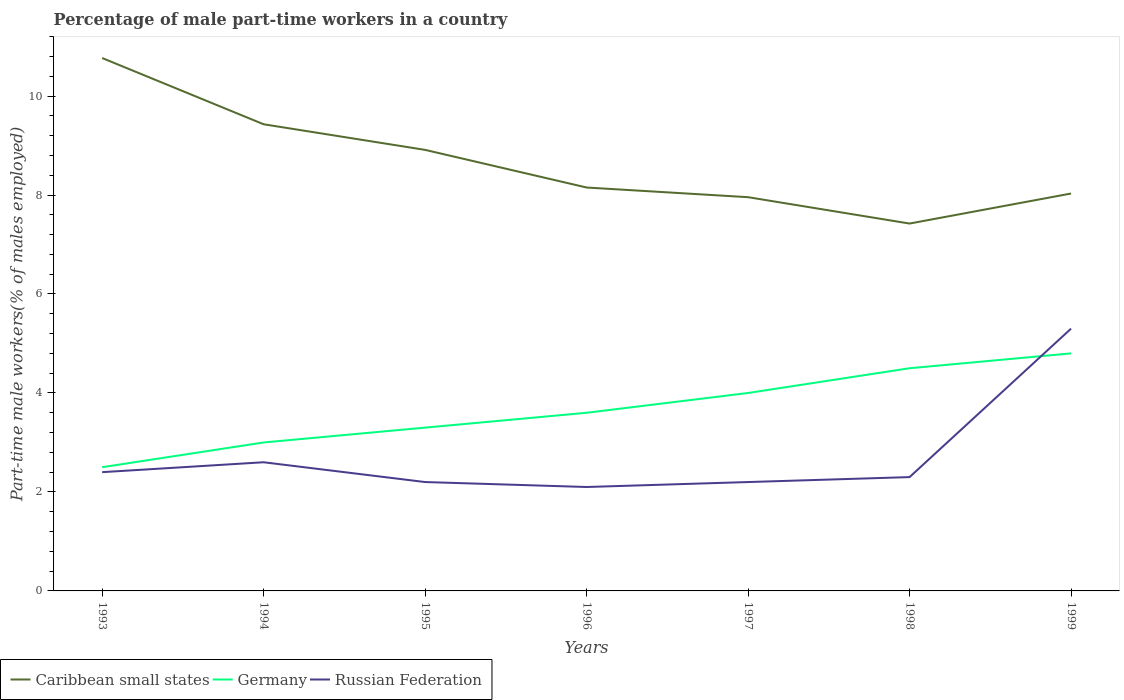Does the line corresponding to Germany intersect with the line corresponding to Russian Federation?
Ensure brevity in your answer.  Yes. Across all years, what is the maximum percentage of male part-time workers in Caribbean small states?
Keep it short and to the point. 7.42. In which year was the percentage of male part-time workers in Caribbean small states maximum?
Offer a very short reply. 1998. What is the total percentage of male part-time workers in Russian Federation in the graph?
Your answer should be compact. 0.1. What is the difference between the highest and the second highest percentage of male part-time workers in Russian Federation?
Keep it short and to the point. 3.2. What is the difference between the highest and the lowest percentage of male part-time workers in Caribbean small states?
Give a very brief answer. 3. How many years are there in the graph?
Your answer should be compact. 7. How many legend labels are there?
Your answer should be very brief. 3. How are the legend labels stacked?
Ensure brevity in your answer.  Horizontal. What is the title of the graph?
Your answer should be compact. Percentage of male part-time workers in a country. What is the label or title of the Y-axis?
Ensure brevity in your answer.  Part-time male workers(% of males employed). What is the Part-time male workers(% of males employed) in Caribbean small states in 1993?
Keep it short and to the point. 10.77. What is the Part-time male workers(% of males employed) in Germany in 1993?
Your answer should be compact. 2.5. What is the Part-time male workers(% of males employed) of Russian Federation in 1993?
Make the answer very short. 2.4. What is the Part-time male workers(% of males employed) of Caribbean small states in 1994?
Provide a short and direct response. 9.43. What is the Part-time male workers(% of males employed) in Russian Federation in 1994?
Your answer should be compact. 2.6. What is the Part-time male workers(% of males employed) of Caribbean small states in 1995?
Your response must be concise. 8.91. What is the Part-time male workers(% of males employed) in Germany in 1995?
Make the answer very short. 3.3. What is the Part-time male workers(% of males employed) of Russian Federation in 1995?
Offer a very short reply. 2.2. What is the Part-time male workers(% of males employed) in Caribbean small states in 1996?
Your response must be concise. 8.15. What is the Part-time male workers(% of males employed) of Germany in 1996?
Your answer should be very brief. 3.6. What is the Part-time male workers(% of males employed) of Russian Federation in 1996?
Keep it short and to the point. 2.1. What is the Part-time male workers(% of males employed) of Caribbean small states in 1997?
Your response must be concise. 7.96. What is the Part-time male workers(% of males employed) in Russian Federation in 1997?
Your answer should be compact. 2.2. What is the Part-time male workers(% of males employed) in Caribbean small states in 1998?
Keep it short and to the point. 7.42. What is the Part-time male workers(% of males employed) in Germany in 1998?
Provide a succinct answer. 4.5. What is the Part-time male workers(% of males employed) of Russian Federation in 1998?
Offer a terse response. 2.3. What is the Part-time male workers(% of males employed) of Caribbean small states in 1999?
Offer a very short reply. 8.03. What is the Part-time male workers(% of males employed) in Germany in 1999?
Provide a short and direct response. 4.8. What is the Part-time male workers(% of males employed) in Russian Federation in 1999?
Give a very brief answer. 5.3. Across all years, what is the maximum Part-time male workers(% of males employed) of Caribbean small states?
Offer a very short reply. 10.77. Across all years, what is the maximum Part-time male workers(% of males employed) of Germany?
Your answer should be compact. 4.8. Across all years, what is the maximum Part-time male workers(% of males employed) of Russian Federation?
Your response must be concise. 5.3. Across all years, what is the minimum Part-time male workers(% of males employed) in Caribbean small states?
Provide a short and direct response. 7.42. Across all years, what is the minimum Part-time male workers(% of males employed) in Russian Federation?
Provide a succinct answer. 2.1. What is the total Part-time male workers(% of males employed) in Caribbean small states in the graph?
Offer a terse response. 60.67. What is the total Part-time male workers(% of males employed) of Germany in the graph?
Provide a short and direct response. 25.7. What is the total Part-time male workers(% of males employed) in Russian Federation in the graph?
Your answer should be very brief. 19.1. What is the difference between the Part-time male workers(% of males employed) of Caribbean small states in 1993 and that in 1994?
Keep it short and to the point. 1.34. What is the difference between the Part-time male workers(% of males employed) in Caribbean small states in 1993 and that in 1995?
Offer a terse response. 1.86. What is the difference between the Part-time male workers(% of males employed) of Caribbean small states in 1993 and that in 1996?
Provide a succinct answer. 2.62. What is the difference between the Part-time male workers(% of males employed) of Germany in 1993 and that in 1996?
Provide a short and direct response. -1.1. What is the difference between the Part-time male workers(% of males employed) in Russian Federation in 1993 and that in 1996?
Your response must be concise. 0.3. What is the difference between the Part-time male workers(% of males employed) of Caribbean small states in 1993 and that in 1997?
Make the answer very short. 2.81. What is the difference between the Part-time male workers(% of males employed) of Caribbean small states in 1993 and that in 1998?
Your answer should be compact. 3.34. What is the difference between the Part-time male workers(% of males employed) of Germany in 1993 and that in 1998?
Provide a short and direct response. -2. What is the difference between the Part-time male workers(% of males employed) of Caribbean small states in 1993 and that in 1999?
Give a very brief answer. 2.74. What is the difference between the Part-time male workers(% of males employed) of Germany in 1993 and that in 1999?
Your answer should be compact. -2.3. What is the difference between the Part-time male workers(% of males employed) in Russian Federation in 1993 and that in 1999?
Your response must be concise. -2.9. What is the difference between the Part-time male workers(% of males employed) in Caribbean small states in 1994 and that in 1995?
Your response must be concise. 0.52. What is the difference between the Part-time male workers(% of males employed) of Germany in 1994 and that in 1995?
Offer a terse response. -0.3. What is the difference between the Part-time male workers(% of males employed) in Russian Federation in 1994 and that in 1995?
Your response must be concise. 0.4. What is the difference between the Part-time male workers(% of males employed) of Caribbean small states in 1994 and that in 1996?
Your answer should be very brief. 1.28. What is the difference between the Part-time male workers(% of males employed) of Germany in 1994 and that in 1996?
Make the answer very short. -0.6. What is the difference between the Part-time male workers(% of males employed) of Caribbean small states in 1994 and that in 1997?
Your answer should be very brief. 1.47. What is the difference between the Part-time male workers(% of males employed) of Russian Federation in 1994 and that in 1997?
Your answer should be very brief. 0.4. What is the difference between the Part-time male workers(% of males employed) in Caribbean small states in 1994 and that in 1998?
Your answer should be compact. 2.01. What is the difference between the Part-time male workers(% of males employed) of Germany in 1994 and that in 1998?
Keep it short and to the point. -1.5. What is the difference between the Part-time male workers(% of males employed) of Caribbean small states in 1994 and that in 1999?
Your answer should be compact. 1.4. What is the difference between the Part-time male workers(% of males employed) of Caribbean small states in 1995 and that in 1996?
Your answer should be very brief. 0.76. What is the difference between the Part-time male workers(% of males employed) in Germany in 1995 and that in 1996?
Your answer should be compact. -0.3. What is the difference between the Part-time male workers(% of males employed) of Russian Federation in 1995 and that in 1996?
Give a very brief answer. 0.1. What is the difference between the Part-time male workers(% of males employed) in Caribbean small states in 1995 and that in 1997?
Offer a terse response. 0.96. What is the difference between the Part-time male workers(% of males employed) of Caribbean small states in 1995 and that in 1998?
Your response must be concise. 1.49. What is the difference between the Part-time male workers(% of males employed) in Russian Federation in 1995 and that in 1998?
Ensure brevity in your answer.  -0.1. What is the difference between the Part-time male workers(% of males employed) in Caribbean small states in 1995 and that in 1999?
Offer a very short reply. 0.88. What is the difference between the Part-time male workers(% of males employed) of Caribbean small states in 1996 and that in 1997?
Offer a terse response. 0.2. What is the difference between the Part-time male workers(% of males employed) in Germany in 1996 and that in 1997?
Your response must be concise. -0.4. What is the difference between the Part-time male workers(% of males employed) in Russian Federation in 1996 and that in 1997?
Your response must be concise. -0.1. What is the difference between the Part-time male workers(% of males employed) of Caribbean small states in 1996 and that in 1998?
Provide a succinct answer. 0.73. What is the difference between the Part-time male workers(% of males employed) of Germany in 1996 and that in 1998?
Your answer should be very brief. -0.9. What is the difference between the Part-time male workers(% of males employed) in Russian Federation in 1996 and that in 1998?
Provide a short and direct response. -0.2. What is the difference between the Part-time male workers(% of males employed) of Caribbean small states in 1996 and that in 1999?
Keep it short and to the point. 0.12. What is the difference between the Part-time male workers(% of males employed) in Germany in 1996 and that in 1999?
Ensure brevity in your answer.  -1.2. What is the difference between the Part-time male workers(% of males employed) of Russian Federation in 1996 and that in 1999?
Your answer should be compact. -3.2. What is the difference between the Part-time male workers(% of males employed) of Caribbean small states in 1997 and that in 1998?
Provide a short and direct response. 0.53. What is the difference between the Part-time male workers(% of males employed) in Russian Federation in 1997 and that in 1998?
Make the answer very short. -0.1. What is the difference between the Part-time male workers(% of males employed) of Caribbean small states in 1997 and that in 1999?
Make the answer very short. -0.07. What is the difference between the Part-time male workers(% of males employed) of Germany in 1997 and that in 1999?
Provide a short and direct response. -0.8. What is the difference between the Part-time male workers(% of males employed) in Caribbean small states in 1998 and that in 1999?
Your answer should be compact. -0.61. What is the difference between the Part-time male workers(% of males employed) of Russian Federation in 1998 and that in 1999?
Your answer should be compact. -3. What is the difference between the Part-time male workers(% of males employed) in Caribbean small states in 1993 and the Part-time male workers(% of males employed) in Germany in 1994?
Offer a very short reply. 7.77. What is the difference between the Part-time male workers(% of males employed) in Caribbean small states in 1993 and the Part-time male workers(% of males employed) in Russian Federation in 1994?
Your answer should be compact. 8.17. What is the difference between the Part-time male workers(% of males employed) of Caribbean small states in 1993 and the Part-time male workers(% of males employed) of Germany in 1995?
Keep it short and to the point. 7.47. What is the difference between the Part-time male workers(% of males employed) in Caribbean small states in 1993 and the Part-time male workers(% of males employed) in Russian Federation in 1995?
Offer a terse response. 8.57. What is the difference between the Part-time male workers(% of males employed) of Caribbean small states in 1993 and the Part-time male workers(% of males employed) of Germany in 1996?
Offer a very short reply. 7.17. What is the difference between the Part-time male workers(% of males employed) in Caribbean small states in 1993 and the Part-time male workers(% of males employed) in Russian Federation in 1996?
Your answer should be very brief. 8.67. What is the difference between the Part-time male workers(% of males employed) of Caribbean small states in 1993 and the Part-time male workers(% of males employed) of Germany in 1997?
Provide a succinct answer. 6.77. What is the difference between the Part-time male workers(% of males employed) of Caribbean small states in 1993 and the Part-time male workers(% of males employed) of Russian Federation in 1997?
Your response must be concise. 8.57. What is the difference between the Part-time male workers(% of males employed) in Caribbean small states in 1993 and the Part-time male workers(% of males employed) in Germany in 1998?
Make the answer very short. 6.27. What is the difference between the Part-time male workers(% of males employed) of Caribbean small states in 1993 and the Part-time male workers(% of males employed) of Russian Federation in 1998?
Provide a short and direct response. 8.47. What is the difference between the Part-time male workers(% of males employed) of Caribbean small states in 1993 and the Part-time male workers(% of males employed) of Germany in 1999?
Keep it short and to the point. 5.97. What is the difference between the Part-time male workers(% of males employed) in Caribbean small states in 1993 and the Part-time male workers(% of males employed) in Russian Federation in 1999?
Provide a short and direct response. 5.47. What is the difference between the Part-time male workers(% of males employed) of Caribbean small states in 1994 and the Part-time male workers(% of males employed) of Germany in 1995?
Provide a short and direct response. 6.13. What is the difference between the Part-time male workers(% of males employed) in Caribbean small states in 1994 and the Part-time male workers(% of males employed) in Russian Federation in 1995?
Provide a short and direct response. 7.23. What is the difference between the Part-time male workers(% of males employed) in Caribbean small states in 1994 and the Part-time male workers(% of males employed) in Germany in 1996?
Offer a terse response. 5.83. What is the difference between the Part-time male workers(% of males employed) in Caribbean small states in 1994 and the Part-time male workers(% of males employed) in Russian Federation in 1996?
Offer a terse response. 7.33. What is the difference between the Part-time male workers(% of males employed) in Caribbean small states in 1994 and the Part-time male workers(% of males employed) in Germany in 1997?
Offer a very short reply. 5.43. What is the difference between the Part-time male workers(% of males employed) in Caribbean small states in 1994 and the Part-time male workers(% of males employed) in Russian Federation in 1997?
Offer a very short reply. 7.23. What is the difference between the Part-time male workers(% of males employed) in Caribbean small states in 1994 and the Part-time male workers(% of males employed) in Germany in 1998?
Provide a short and direct response. 4.93. What is the difference between the Part-time male workers(% of males employed) of Caribbean small states in 1994 and the Part-time male workers(% of males employed) of Russian Federation in 1998?
Provide a short and direct response. 7.13. What is the difference between the Part-time male workers(% of males employed) in Caribbean small states in 1994 and the Part-time male workers(% of males employed) in Germany in 1999?
Offer a very short reply. 4.63. What is the difference between the Part-time male workers(% of males employed) in Caribbean small states in 1994 and the Part-time male workers(% of males employed) in Russian Federation in 1999?
Offer a very short reply. 4.13. What is the difference between the Part-time male workers(% of males employed) in Caribbean small states in 1995 and the Part-time male workers(% of males employed) in Germany in 1996?
Provide a short and direct response. 5.31. What is the difference between the Part-time male workers(% of males employed) of Caribbean small states in 1995 and the Part-time male workers(% of males employed) of Russian Federation in 1996?
Offer a very short reply. 6.81. What is the difference between the Part-time male workers(% of males employed) of Germany in 1995 and the Part-time male workers(% of males employed) of Russian Federation in 1996?
Your answer should be very brief. 1.2. What is the difference between the Part-time male workers(% of males employed) in Caribbean small states in 1995 and the Part-time male workers(% of males employed) in Germany in 1997?
Your answer should be compact. 4.91. What is the difference between the Part-time male workers(% of males employed) in Caribbean small states in 1995 and the Part-time male workers(% of males employed) in Russian Federation in 1997?
Your answer should be compact. 6.71. What is the difference between the Part-time male workers(% of males employed) in Caribbean small states in 1995 and the Part-time male workers(% of males employed) in Germany in 1998?
Keep it short and to the point. 4.41. What is the difference between the Part-time male workers(% of males employed) of Caribbean small states in 1995 and the Part-time male workers(% of males employed) of Russian Federation in 1998?
Offer a very short reply. 6.61. What is the difference between the Part-time male workers(% of males employed) of Caribbean small states in 1995 and the Part-time male workers(% of males employed) of Germany in 1999?
Provide a short and direct response. 4.11. What is the difference between the Part-time male workers(% of males employed) in Caribbean small states in 1995 and the Part-time male workers(% of males employed) in Russian Federation in 1999?
Keep it short and to the point. 3.61. What is the difference between the Part-time male workers(% of males employed) of Caribbean small states in 1996 and the Part-time male workers(% of males employed) of Germany in 1997?
Ensure brevity in your answer.  4.15. What is the difference between the Part-time male workers(% of males employed) of Caribbean small states in 1996 and the Part-time male workers(% of males employed) of Russian Federation in 1997?
Your response must be concise. 5.95. What is the difference between the Part-time male workers(% of males employed) of Germany in 1996 and the Part-time male workers(% of males employed) of Russian Federation in 1997?
Provide a short and direct response. 1.4. What is the difference between the Part-time male workers(% of males employed) of Caribbean small states in 1996 and the Part-time male workers(% of males employed) of Germany in 1998?
Your response must be concise. 3.65. What is the difference between the Part-time male workers(% of males employed) of Caribbean small states in 1996 and the Part-time male workers(% of males employed) of Russian Federation in 1998?
Your answer should be compact. 5.85. What is the difference between the Part-time male workers(% of males employed) in Germany in 1996 and the Part-time male workers(% of males employed) in Russian Federation in 1998?
Provide a short and direct response. 1.3. What is the difference between the Part-time male workers(% of males employed) of Caribbean small states in 1996 and the Part-time male workers(% of males employed) of Germany in 1999?
Your answer should be compact. 3.35. What is the difference between the Part-time male workers(% of males employed) of Caribbean small states in 1996 and the Part-time male workers(% of males employed) of Russian Federation in 1999?
Provide a succinct answer. 2.85. What is the difference between the Part-time male workers(% of males employed) in Caribbean small states in 1997 and the Part-time male workers(% of males employed) in Germany in 1998?
Your response must be concise. 3.46. What is the difference between the Part-time male workers(% of males employed) of Caribbean small states in 1997 and the Part-time male workers(% of males employed) of Russian Federation in 1998?
Your answer should be compact. 5.66. What is the difference between the Part-time male workers(% of males employed) of Germany in 1997 and the Part-time male workers(% of males employed) of Russian Federation in 1998?
Offer a very short reply. 1.7. What is the difference between the Part-time male workers(% of males employed) in Caribbean small states in 1997 and the Part-time male workers(% of males employed) in Germany in 1999?
Make the answer very short. 3.16. What is the difference between the Part-time male workers(% of males employed) of Caribbean small states in 1997 and the Part-time male workers(% of males employed) of Russian Federation in 1999?
Give a very brief answer. 2.66. What is the difference between the Part-time male workers(% of males employed) of Germany in 1997 and the Part-time male workers(% of males employed) of Russian Federation in 1999?
Provide a short and direct response. -1.3. What is the difference between the Part-time male workers(% of males employed) of Caribbean small states in 1998 and the Part-time male workers(% of males employed) of Germany in 1999?
Offer a terse response. 2.62. What is the difference between the Part-time male workers(% of males employed) in Caribbean small states in 1998 and the Part-time male workers(% of males employed) in Russian Federation in 1999?
Offer a very short reply. 2.12. What is the average Part-time male workers(% of males employed) of Caribbean small states per year?
Ensure brevity in your answer.  8.67. What is the average Part-time male workers(% of males employed) of Germany per year?
Your response must be concise. 3.67. What is the average Part-time male workers(% of males employed) of Russian Federation per year?
Ensure brevity in your answer.  2.73. In the year 1993, what is the difference between the Part-time male workers(% of males employed) of Caribbean small states and Part-time male workers(% of males employed) of Germany?
Your answer should be compact. 8.27. In the year 1993, what is the difference between the Part-time male workers(% of males employed) of Caribbean small states and Part-time male workers(% of males employed) of Russian Federation?
Give a very brief answer. 8.37. In the year 1994, what is the difference between the Part-time male workers(% of males employed) of Caribbean small states and Part-time male workers(% of males employed) of Germany?
Make the answer very short. 6.43. In the year 1994, what is the difference between the Part-time male workers(% of males employed) in Caribbean small states and Part-time male workers(% of males employed) in Russian Federation?
Keep it short and to the point. 6.83. In the year 1995, what is the difference between the Part-time male workers(% of males employed) of Caribbean small states and Part-time male workers(% of males employed) of Germany?
Give a very brief answer. 5.61. In the year 1995, what is the difference between the Part-time male workers(% of males employed) in Caribbean small states and Part-time male workers(% of males employed) in Russian Federation?
Offer a terse response. 6.71. In the year 1995, what is the difference between the Part-time male workers(% of males employed) in Germany and Part-time male workers(% of males employed) in Russian Federation?
Give a very brief answer. 1.1. In the year 1996, what is the difference between the Part-time male workers(% of males employed) of Caribbean small states and Part-time male workers(% of males employed) of Germany?
Your answer should be very brief. 4.55. In the year 1996, what is the difference between the Part-time male workers(% of males employed) in Caribbean small states and Part-time male workers(% of males employed) in Russian Federation?
Offer a terse response. 6.05. In the year 1996, what is the difference between the Part-time male workers(% of males employed) of Germany and Part-time male workers(% of males employed) of Russian Federation?
Provide a succinct answer. 1.5. In the year 1997, what is the difference between the Part-time male workers(% of males employed) in Caribbean small states and Part-time male workers(% of males employed) in Germany?
Keep it short and to the point. 3.96. In the year 1997, what is the difference between the Part-time male workers(% of males employed) of Caribbean small states and Part-time male workers(% of males employed) of Russian Federation?
Offer a very short reply. 5.76. In the year 1997, what is the difference between the Part-time male workers(% of males employed) of Germany and Part-time male workers(% of males employed) of Russian Federation?
Provide a short and direct response. 1.8. In the year 1998, what is the difference between the Part-time male workers(% of males employed) of Caribbean small states and Part-time male workers(% of males employed) of Germany?
Provide a succinct answer. 2.92. In the year 1998, what is the difference between the Part-time male workers(% of males employed) of Caribbean small states and Part-time male workers(% of males employed) of Russian Federation?
Offer a very short reply. 5.12. In the year 1999, what is the difference between the Part-time male workers(% of males employed) of Caribbean small states and Part-time male workers(% of males employed) of Germany?
Your response must be concise. 3.23. In the year 1999, what is the difference between the Part-time male workers(% of males employed) of Caribbean small states and Part-time male workers(% of males employed) of Russian Federation?
Your response must be concise. 2.73. In the year 1999, what is the difference between the Part-time male workers(% of males employed) in Germany and Part-time male workers(% of males employed) in Russian Federation?
Offer a terse response. -0.5. What is the ratio of the Part-time male workers(% of males employed) in Caribbean small states in 1993 to that in 1994?
Your answer should be compact. 1.14. What is the ratio of the Part-time male workers(% of males employed) in Russian Federation in 1993 to that in 1994?
Provide a succinct answer. 0.92. What is the ratio of the Part-time male workers(% of males employed) in Caribbean small states in 1993 to that in 1995?
Give a very brief answer. 1.21. What is the ratio of the Part-time male workers(% of males employed) of Germany in 1993 to that in 1995?
Your answer should be very brief. 0.76. What is the ratio of the Part-time male workers(% of males employed) of Russian Federation in 1993 to that in 1995?
Offer a very short reply. 1.09. What is the ratio of the Part-time male workers(% of males employed) of Caribbean small states in 1993 to that in 1996?
Keep it short and to the point. 1.32. What is the ratio of the Part-time male workers(% of males employed) in Germany in 1993 to that in 1996?
Keep it short and to the point. 0.69. What is the ratio of the Part-time male workers(% of males employed) of Caribbean small states in 1993 to that in 1997?
Offer a terse response. 1.35. What is the ratio of the Part-time male workers(% of males employed) in Germany in 1993 to that in 1997?
Your response must be concise. 0.62. What is the ratio of the Part-time male workers(% of males employed) of Russian Federation in 1993 to that in 1997?
Your response must be concise. 1.09. What is the ratio of the Part-time male workers(% of males employed) in Caribbean small states in 1993 to that in 1998?
Offer a terse response. 1.45. What is the ratio of the Part-time male workers(% of males employed) of Germany in 1993 to that in 1998?
Your answer should be compact. 0.56. What is the ratio of the Part-time male workers(% of males employed) of Russian Federation in 1993 to that in 1998?
Ensure brevity in your answer.  1.04. What is the ratio of the Part-time male workers(% of males employed) of Caribbean small states in 1993 to that in 1999?
Give a very brief answer. 1.34. What is the ratio of the Part-time male workers(% of males employed) in Germany in 1993 to that in 1999?
Provide a succinct answer. 0.52. What is the ratio of the Part-time male workers(% of males employed) in Russian Federation in 1993 to that in 1999?
Provide a short and direct response. 0.45. What is the ratio of the Part-time male workers(% of males employed) in Caribbean small states in 1994 to that in 1995?
Your answer should be compact. 1.06. What is the ratio of the Part-time male workers(% of males employed) in Russian Federation in 1994 to that in 1995?
Provide a short and direct response. 1.18. What is the ratio of the Part-time male workers(% of males employed) in Caribbean small states in 1994 to that in 1996?
Your answer should be very brief. 1.16. What is the ratio of the Part-time male workers(% of males employed) of Russian Federation in 1994 to that in 1996?
Provide a short and direct response. 1.24. What is the ratio of the Part-time male workers(% of males employed) of Caribbean small states in 1994 to that in 1997?
Keep it short and to the point. 1.19. What is the ratio of the Part-time male workers(% of males employed) in Germany in 1994 to that in 1997?
Provide a succinct answer. 0.75. What is the ratio of the Part-time male workers(% of males employed) of Russian Federation in 1994 to that in 1997?
Your answer should be compact. 1.18. What is the ratio of the Part-time male workers(% of males employed) in Caribbean small states in 1994 to that in 1998?
Your response must be concise. 1.27. What is the ratio of the Part-time male workers(% of males employed) in Germany in 1994 to that in 1998?
Provide a short and direct response. 0.67. What is the ratio of the Part-time male workers(% of males employed) of Russian Federation in 1994 to that in 1998?
Provide a short and direct response. 1.13. What is the ratio of the Part-time male workers(% of males employed) in Caribbean small states in 1994 to that in 1999?
Give a very brief answer. 1.17. What is the ratio of the Part-time male workers(% of males employed) in Germany in 1994 to that in 1999?
Offer a very short reply. 0.62. What is the ratio of the Part-time male workers(% of males employed) in Russian Federation in 1994 to that in 1999?
Ensure brevity in your answer.  0.49. What is the ratio of the Part-time male workers(% of males employed) in Caribbean small states in 1995 to that in 1996?
Offer a very short reply. 1.09. What is the ratio of the Part-time male workers(% of males employed) of Russian Federation in 1995 to that in 1996?
Your answer should be very brief. 1.05. What is the ratio of the Part-time male workers(% of males employed) in Caribbean small states in 1995 to that in 1997?
Your response must be concise. 1.12. What is the ratio of the Part-time male workers(% of males employed) of Germany in 1995 to that in 1997?
Offer a very short reply. 0.82. What is the ratio of the Part-time male workers(% of males employed) of Caribbean small states in 1995 to that in 1998?
Your answer should be compact. 1.2. What is the ratio of the Part-time male workers(% of males employed) in Germany in 1995 to that in 1998?
Provide a succinct answer. 0.73. What is the ratio of the Part-time male workers(% of males employed) in Russian Federation in 1995 to that in 1998?
Offer a very short reply. 0.96. What is the ratio of the Part-time male workers(% of males employed) of Caribbean small states in 1995 to that in 1999?
Keep it short and to the point. 1.11. What is the ratio of the Part-time male workers(% of males employed) in Germany in 1995 to that in 1999?
Your answer should be very brief. 0.69. What is the ratio of the Part-time male workers(% of males employed) in Russian Federation in 1995 to that in 1999?
Keep it short and to the point. 0.42. What is the ratio of the Part-time male workers(% of males employed) of Caribbean small states in 1996 to that in 1997?
Keep it short and to the point. 1.02. What is the ratio of the Part-time male workers(% of males employed) of Germany in 1996 to that in 1997?
Your answer should be very brief. 0.9. What is the ratio of the Part-time male workers(% of males employed) in Russian Federation in 1996 to that in 1997?
Provide a short and direct response. 0.95. What is the ratio of the Part-time male workers(% of males employed) in Caribbean small states in 1996 to that in 1998?
Make the answer very short. 1.1. What is the ratio of the Part-time male workers(% of males employed) of Caribbean small states in 1996 to that in 1999?
Your response must be concise. 1.02. What is the ratio of the Part-time male workers(% of males employed) of Germany in 1996 to that in 1999?
Your answer should be very brief. 0.75. What is the ratio of the Part-time male workers(% of males employed) of Russian Federation in 1996 to that in 1999?
Your answer should be very brief. 0.4. What is the ratio of the Part-time male workers(% of males employed) in Caribbean small states in 1997 to that in 1998?
Your response must be concise. 1.07. What is the ratio of the Part-time male workers(% of males employed) of Russian Federation in 1997 to that in 1998?
Provide a short and direct response. 0.96. What is the ratio of the Part-time male workers(% of males employed) in Russian Federation in 1997 to that in 1999?
Your response must be concise. 0.42. What is the ratio of the Part-time male workers(% of males employed) of Caribbean small states in 1998 to that in 1999?
Provide a short and direct response. 0.92. What is the ratio of the Part-time male workers(% of males employed) of Germany in 1998 to that in 1999?
Your answer should be compact. 0.94. What is the ratio of the Part-time male workers(% of males employed) of Russian Federation in 1998 to that in 1999?
Offer a very short reply. 0.43. What is the difference between the highest and the second highest Part-time male workers(% of males employed) in Caribbean small states?
Make the answer very short. 1.34. What is the difference between the highest and the second highest Part-time male workers(% of males employed) in Germany?
Offer a terse response. 0.3. What is the difference between the highest and the second highest Part-time male workers(% of males employed) in Russian Federation?
Provide a succinct answer. 2.7. What is the difference between the highest and the lowest Part-time male workers(% of males employed) in Caribbean small states?
Give a very brief answer. 3.34. What is the difference between the highest and the lowest Part-time male workers(% of males employed) of Russian Federation?
Provide a succinct answer. 3.2. 